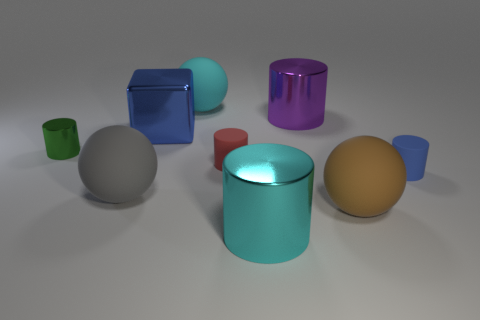Are there more cyan metallic cylinders left of the big purple object than big yellow metal objects?
Ensure brevity in your answer.  Yes. Does the cyan object that is behind the purple thing have the same shape as the brown matte thing?
Offer a very short reply. Yes. How many yellow objects are tiny rubber cylinders or metal cylinders?
Provide a short and direct response. 0. Is the number of large objects greater than the number of big yellow cubes?
Make the answer very short. Yes. What color is the metal cube that is the same size as the cyan metallic thing?
Ensure brevity in your answer.  Blue. What number of cylinders are gray things or rubber objects?
Keep it short and to the point. 2. Does the small blue thing have the same shape as the big shiny object to the left of the cyan rubber ball?
Give a very brief answer. No. How many blue rubber cylinders have the same size as the green metal object?
Ensure brevity in your answer.  1. There is a big cyan thing that is behind the big purple cylinder; is its shape the same as the large gray rubber thing that is in front of the small green metal cylinder?
Offer a very short reply. Yes. The thing that is the same color as the block is what shape?
Your answer should be very brief. Cylinder. 